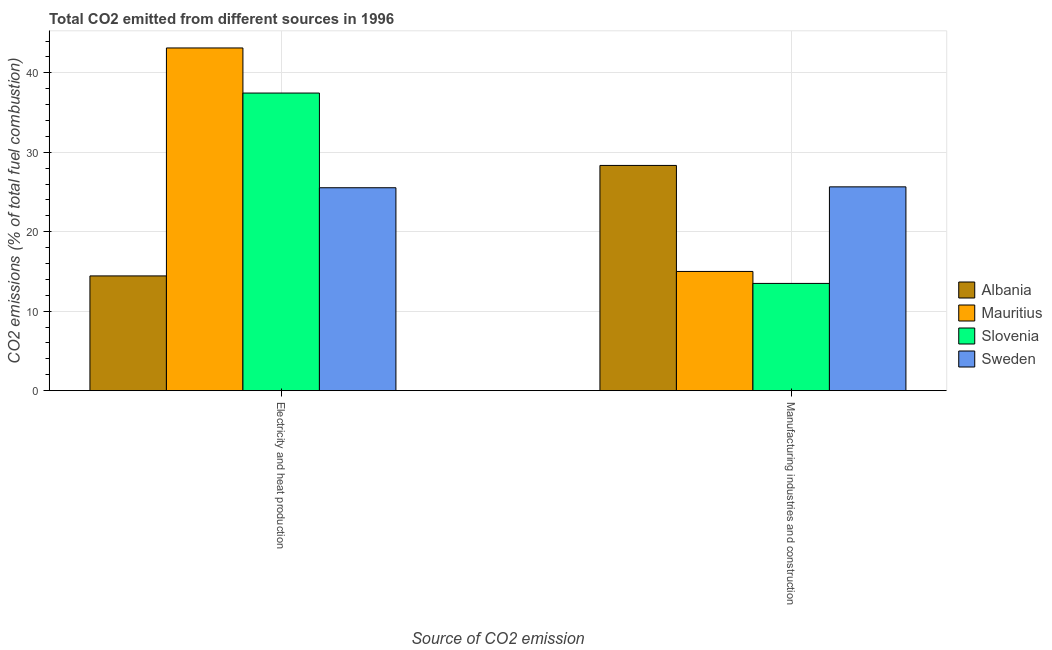Are the number of bars per tick equal to the number of legend labels?
Your response must be concise. Yes. How many bars are there on the 2nd tick from the left?
Keep it short and to the point. 4. What is the label of the 2nd group of bars from the left?
Your answer should be compact. Manufacturing industries and construction. What is the co2 emissions due to manufacturing industries in Albania?
Provide a short and direct response. 28.34. Across all countries, what is the maximum co2 emissions due to manufacturing industries?
Your answer should be very brief. 28.34. Across all countries, what is the minimum co2 emissions due to electricity and heat production?
Provide a short and direct response. 14.44. In which country was the co2 emissions due to electricity and heat production maximum?
Offer a terse response. Mauritius. In which country was the co2 emissions due to electricity and heat production minimum?
Offer a terse response. Albania. What is the total co2 emissions due to manufacturing industries in the graph?
Your response must be concise. 82.48. What is the difference between the co2 emissions due to electricity and heat production in Mauritius and that in Sweden?
Make the answer very short. 17.59. What is the difference between the co2 emissions due to electricity and heat production in Mauritius and the co2 emissions due to manufacturing industries in Sweden?
Make the answer very short. 17.48. What is the average co2 emissions due to manufacturing industries per country?
Your answer should be very brief. 20.62. What is the difference between the co2 emissions due to electricity and heat production and co2 emissions due to manufacturing industries in Mauritius?
Make the answer very short. 28.12. In how many countries, is the co2 emissions due to manufacturing industries greater than 8 %?
Your answer should be compact. 4. What is the ratio of the co2 emissions due to manufacturing industries in Slovenia to that in Sweden?
Make the answer very short. 0.53. Is the co2 emissions due to electricity and heat production in Albania less than that in Sweden?
Keep it short and to the point. Yes. In how many countries, is the co2 emissions due to manufacturing industries greater than the average co2 emissions due to manufacturing industries taken over all countries?
Give a very brief answer. 2. What does the 2nd bar from the left in Manufacturing industries and construction represents?
Provide a short and direct response. Mauritius. What does the 4th bar from the right in Manufacturing industries and construction represents?
Your answer should be very brief. Albania. Are the values on the major ticks of Y-axis written in scientific E-notation?
Your answer should be compact. No. Does the graph contain grids?
Your response must be concise. Yes. How are the legend labels stacked?
Your answer should be compact. Vertical. What is the title of the graph?
Provide a short and direct response. Total CO2 emitted from different sources in 1996. Does "Guinea-Bissau" appear as one of the legend labels in the graph?
Make the answer very short. No. What is the label or title of the X-axis?
Make the answer very short. Source of CO2 emission. What is the label or title of the Y-axis?
Provide a short and direct response. CO2 emissions (% of total fuel combustion). What is the CO2 emissions (% of total fuel combustion) of Albania in Electricity and heat production?
Provide a short and direct response. 14.44. What is the CO2 emissions (% of total fuel combustion) in Mauritius in Electricity and heat production?
Your answer should be very brief. 43.12. What is the CO2 emissions (% of total fuel combustion) of Slovenia in Electricity and heat production?
Your response must be concise. 37.45. What is the CO2 emissions (% of total fuel combustion) of Sweden in Electricity and heat production?
Your answer should be very brief. 25.53. What is the CO2 emissions (% of total fuel combustion) of Albania in Manufacturing industries and construction?
Your answer should be very brief. 28.34. What is the CO2 emissions (% of total fuel combustion) of Mauritius in Manufacturing industries and construction?
Keep it short and to the point. 15. What is the CO2 emissions (% of total fuel combustion) in Slovenia in Manufacturing industries and construction?
Your response must be concise. 13.5. What is the CO2 emissions (% of total fuel combustion) of Sweden in Manufacturing industries and construction?
Offer a very short reply. 25.65. Across all Source of CO2 emission, what is the maximum CO2 emissions (% of total fuel combustion) in Albania?
Provide a short and direct response. 28.34. Across all Source of CO2 emission, what is the maximum CO2 emissions (% of total fuel combustion) of Mauritius?
Make the answer very short. 43.12. Across all Source of CO2 emission, what is the maximum CO2 emissions (% of total fuel combustion) in Slovenia?
Offer a very short reply. 37.45. Across all Source of CO2 emission, what is the maximum CO2 emissions (% of total fuel combustion) of Sweden?
Give a very brief answer. 25.65. Across all Source of CO2 emission, what is the minimum CO2 emissions (% of total fuel combustion) in Albania?
Your response must be concise. 14.44. Across all Source of CO2 emission, what is the minimum CO2 emissions (% of total fuel combustion) of Slovenia?
Give a very brief answer. 13.5. Across all Source of CO2 emission, what is the minimum CO2 emissions (% of total fuel combustion) of Sweden?
Your response must be concise. 25.53. What is the total CO2 emissions (% of total fuel combustion) in Albania in the graph?
Your answer should be very brief. 42.78. What is the total CO2 emissions (% of total fuel combustion) of Mauritius in the graph?
Your answer should be compact. 58.12. What is the total CO2 emissions (% of total fuel combustion) of Slovenia in the graph?
Offer a terse response. 50.94. What is the total CO2 emissions (% of total fuel combustion) in Sweden in the graph?
Ensure brevity in your answer.  51.18. What is the difference between the CO2 emissions (% of total fuel combustion) of Albania in Electricity and heat production and that in Manufacturing industries and construction?
Provide a short and direct response. -13.9. What is the difference between the CO2 emissions (% of total fuel combustion) of Mauritius in Electricity and heat production and that in Manufacturing industries and construction?
Your answer should be compact. 28.12. What is the difference between the CO2 emissions (% of total fuel combustion) in Slovenia in Electricity and heat production and that in Manufacturing industries and construction?
Your answer should be compact. 23.95. What is the difference between the CO2 emissions (% of total fuel combustion) in Sweden in Electricity and heat production and that in Manufacturing industries and construction?
Make the answer very short. -0.11. What is the difference between the CO2 emissions (% of total fuel combustion) of Albania in Electricity and heat production and the CO2 emissions (% of total fuel combustion) of Mauritius in Manufacturing industries and construction?
Offer a terse response. -0.56. What is the difference between the CO2 emissions (% of total fuel combustion) in Albania in Electricity and heat production and the CO2 emissions (% of total fuel combustion) in Slovenia in Manufacturing industries and construction?
Offer a very short reply. 0.94. What is the difference between the CO2 emissions (% of total fuel combustion) of Albania in Electricity and heat production and the CO2 emissions (% of total fuel combustion) of Sweden in Manufacturing industries and construction?
Keep it short and to the point. -11.21. What is the difference between the CO2 emissions (% of total fuel combustion) in Mauritius in Electricity and heat production and the CO2 emissions (% of total fuel combustion) in Slovenia in Manufacturing industries and construction?
Your answer should be compact. 29.63. What is the difference between the CO2 emissions (% of total fuel combustion) of Mauritius in Electricity and heat production and the CO2 emissions (% of total fuel combustion) of Sweden in Manufacturing industries and construction?
Ensure brevity in your answer.  17.48. What is the difference between the CO2 emissions (% of total fuel combustion) of Slovenia in Electricity and heat production and the CO2 emissions (% of total fuel combustion) of Sweden in Manufacturing industries and construction?
Your response must be concise. 11.8. What is the average CO2 emissions (% of total fuel combustion) in Albania per Source of CO2 emission?
Offer a terse response. 21.39. What is the average CO2 emissions (% of total fuel combustion) in Mauritius per Source of CO2 emission?
Provide a short and direct response. 29.06. What is the average CO2 emissions (% of total fuel combustion) of Slovenia per Source of CO2 emission?
Ensure brevity in your answer.  25.47. What is the average CO2 emissions (% of total fuel combustion) in Sweden per Source of CO2 emission?
Provide a succinct answer. 25.59. What is the difference between the CO2 emissions (% of total fuel combustion) of Albania and CO2 emissions (% of total fuel combustion) of Mauritius in Electricity and heat production?
Give a very brief answer. -28.69. What is the difference between the CO2 emissions (% of total fuel combustion) of Albania and CO2 emissions (% of total fuel combustion) of Slovenia in Electricity and heat production?
Provide a succinct answer. -23.01. What is the difference between the CO2 emissions (% of total fuel combustion) of Albania and CO2 emissions (% of total fuel combustion) of Sweden in Electricity and heat production?
Ensure brevity in your answer.  -11.1. What is the difference between the CO2 emissions (% of total fuel combustion) of Mauritius and CO2 emissions (% of total fuel combustion) of Slovenia in Electricity and heat production?
Offer a terse response. 5.68. What is the difference between the CO2 emissions (% of total fuel combustion) of Mauritius and CO2 emissions (% of total fuel combustion) of Sweden in Electricity and heat production?
Make the answer very short. 17.59. What is the difference between the CO2 emissions (% of total fuel combustion) in Slovenia and CO2 emissions (% of total fuel combustion) in Sweden in Electricity and heat production?
Offer a terse response. 11.91. What is the difference between the CO2 emissions (% of total fuel combustion) of Albania and CO2 emissions (% of total fuel combustion) of Mauritius in Manufacturing industries and construction?
Keep it short and to the point. 13.34. What is the difference between the CO2 emissions (% of total fuel combustion) in Albania and CO2 emissions (% of total fuel combustion) in Slovenia in Manufacturing industries and construction?
Ensure brevity in your answer.  14.85. What is the difference between the CO2 emissions (% of total fuel combustion) of Albania and CO2 emissions (% of total fuel combustion) of Sweden in Manufacturing industries and construction?
Make the answer very short. 2.7. What is the difference between the CO2 emissions (% of total fuel combustion) of Mauritius and CO2 emissions (% of total fuel combustion) of Slovenia in Manufacturing industries and construction?
Ensure brevity in your answer.  1.5. What is the difference between the CO2 emissions (% of total fuel combustion) of Mauritius and CO2 emissions (% of total fuel combustion) of Sweden in Manufacturing industries and construction?
Provide a short and direct response. -10.65. What is the difference between the CO2 emissions (% of total fuel combustion) of Slovenia and CO2 emissions (% of total fuel combustion) of Sweden in Manufacturing industries and construction?
Provide a short and direct response. -12.15. What is the ratio of the CO2 emissions (% of total fuel combustion) in Albania in Electricity and heat production to that in Manufacturing industries and construction?
Make the answer very short. 0.51. What is the ratio of the CO2 emissions (% of total fuel combustion) of Mauritius in Electricity and heat production to that in Manufacturing industries and construction?
Your response must be concise. 2.88. What is the ratio of the CO2 emissions (% of total fuel combustion) in Slovenia in Electricity and heat production to that in Manufacturing industries and construction?
Provide a succinct answer. 2.77. What is the difference between the highest and the second highest CO2 emissions (% of total fuel combustion) of Albania?
Your answer should be very brief. 13.9. What is the difference between the highest and the second highest CO2 emissions (% of total fuel combustion) of Mauritius?
Offer a terse response. 28.12. What is the difference between the highest and the second highest CO2 emissions (% of total fuel combustion) of Slovenia?
Your response must be concise. 23.95. What is the difference between the highest and the second highest CO2 emissions (% of total fuel combustion) of Sweden?
Offer a terse response. 0.11. What is the difference between the highest and the lowest CO2 emissions (% of total fuel combustion) in Albania?
Make the answer very short. 13.9. What is the difference between the highest and the lowest CO2 emissions (% of total fuel combustion) of Mauritius?
Your answer should be compact. 28.12. What is the difference between the highest and the lowest CO2 emissions (% of total fuel combustion) of Slovenia?
Your response must be concise. 23.95. What is the difference between the highest and the lowest CO2 emissions (% of total fuel combustion) of Sweden?
Your response must be concise. 0.11. 